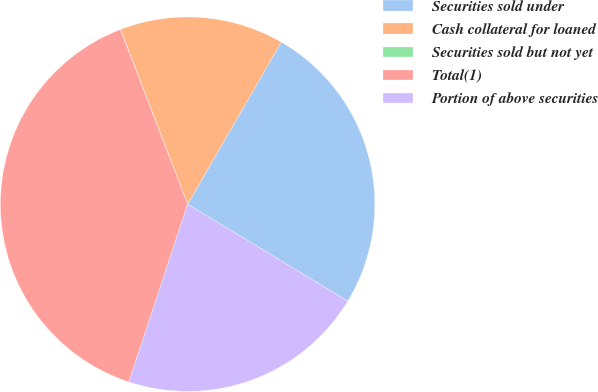<chart> <loc_0><loc_0><loc_500><loc_500><pie_chart><fcel>Securities sold under<fcel>Cash collateral for loaned<fcel>Securities sold but not yet<fcel>Total(1)<fcel>Portion of above securities<nl><fcel>25.32%<fcel>14.17%<fcel>0.02%<fcel>39.07%<fcel>21.42%<nl></chart> 